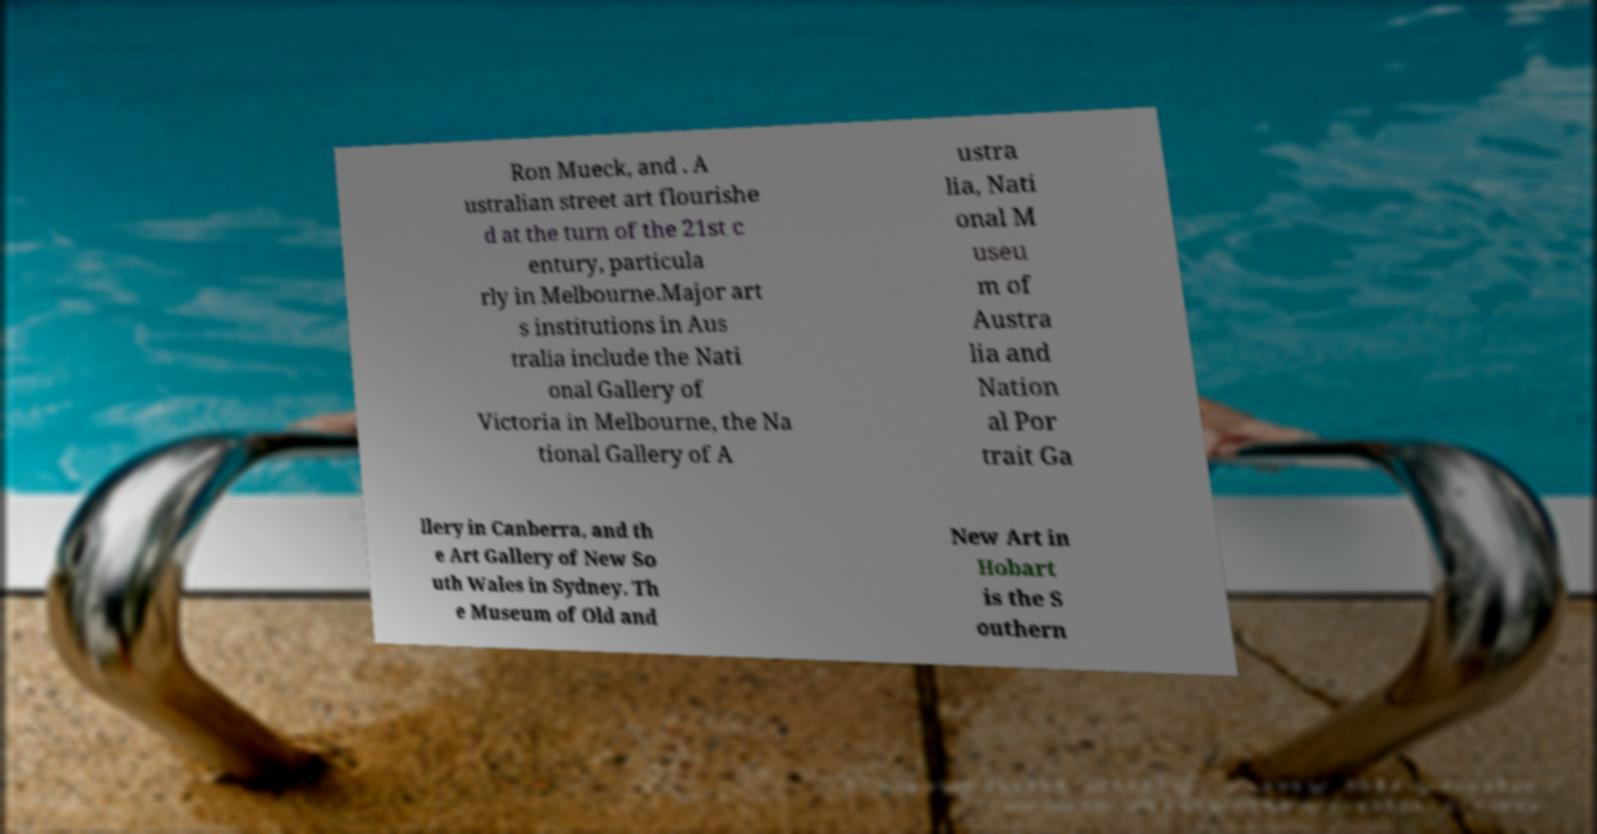Can you read and provide the text displayed in the image?This photo seems to have some interesting text. Can you extract and type it out for me? Ron Mueck, and . A ustralian street art flourishe d at the turn of the 21st c entury, particula rly in Melbourne.Major art s institutions in Aus tralia include the Nati onal Gallery of Victoria in Melbourne, the Na tional Gallery of A ustra lia, Nati onal M useu m of Austra lia and Nation al Por trait Ga llery in Canberra, and th e Art Gallery of New So uth Wales in Sydney. Th e Museum of Old and New Art in Hobart is the S outhern 